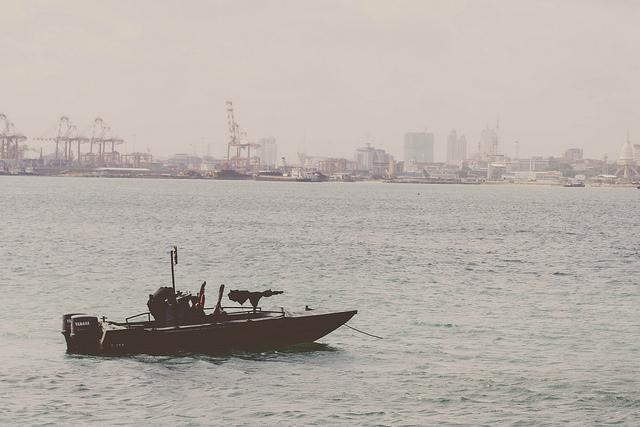How many boats are visible?
Give a very brief answer. 1. 